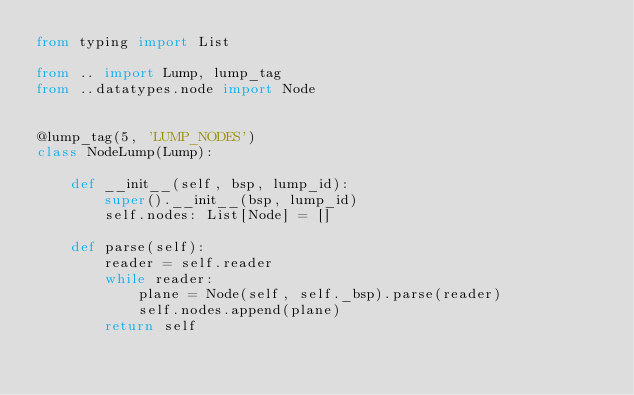Convert code to text. <code><loc_0><loc_0><loc_500><loc_500><_Python_>from typing import List

from .. import Lump, lump_tag
from ..datatypes.node import Node


@lump_tag(5, 'LUMP_NODES')
class NodeLump(Lump):

    def __init__(self, bsp, lump_id):
        super().__init__(bsp, lump_id)
        self.nodes: List[Node] = []

    def parse(self):
        reader = self.reader
        while reader:
            plane = Node(self, self._bsp).parse(reader)
            self.nodes.append(plane)
        return self
</code> 